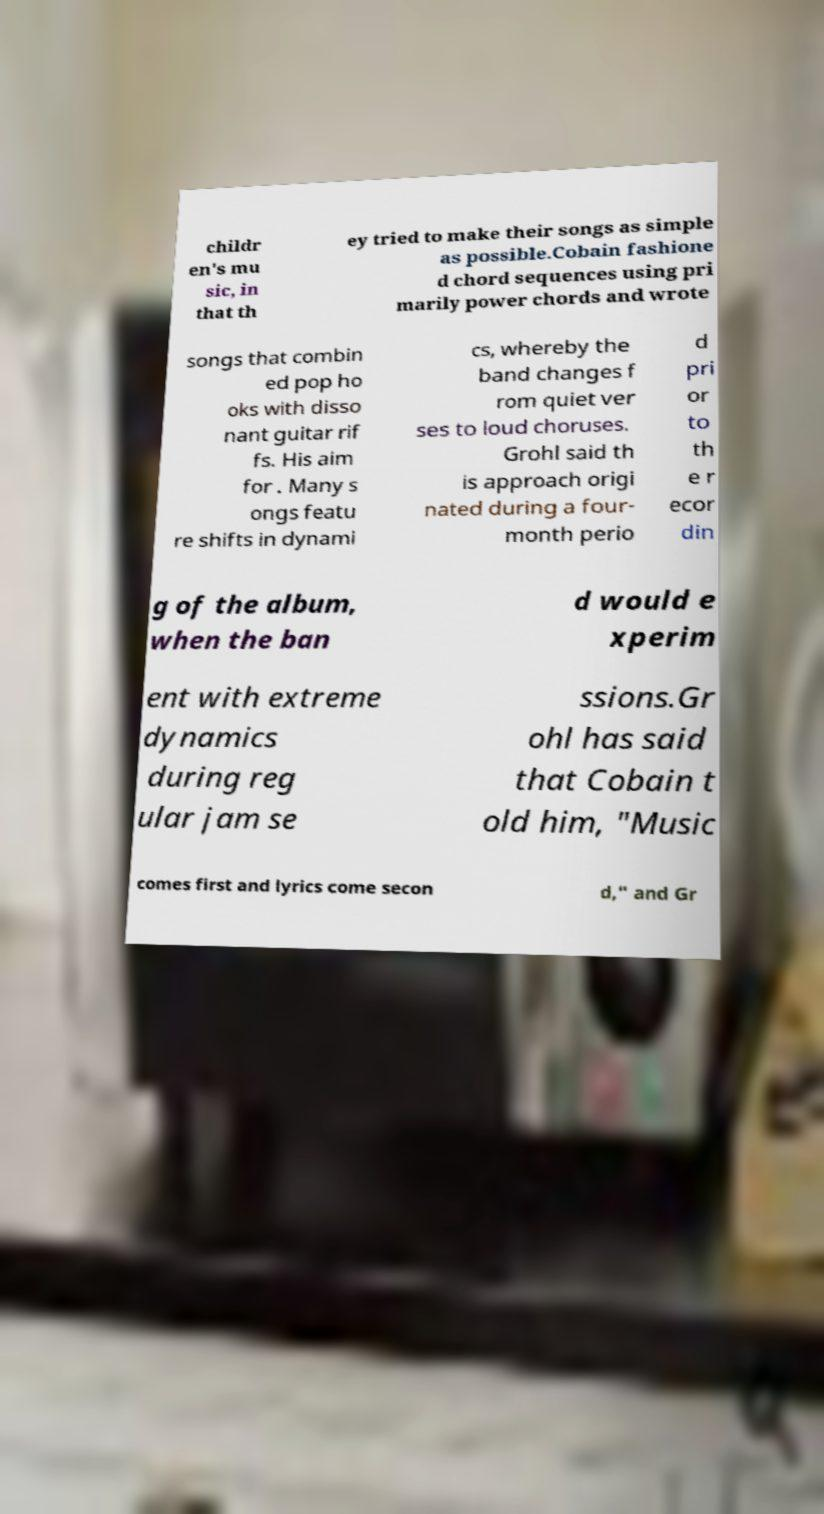Please identify and transcribe the text found in this image. childr en's mu sic, in that th ey tried to make their songs as simple as possible.Cobain fashione d chord sequences using pri marily power chords and wrote songs that combin ed pop ho oks with disso nant guitar rif fs. His aim for . Many s ongs featu re shifts in dynami cs, whereby the band changes f rom quiet ver ses to loud choruses. Grohl said th is approach origi nated during a four- month perio d pri or to th e r ecor din g of the album, when the ban d would e xperim ent with extreme dynamics during reg ular jam se ssions.Gr ohl has said that Cobain t old him, "Music comes first and lyrics come secon d," and Gr 